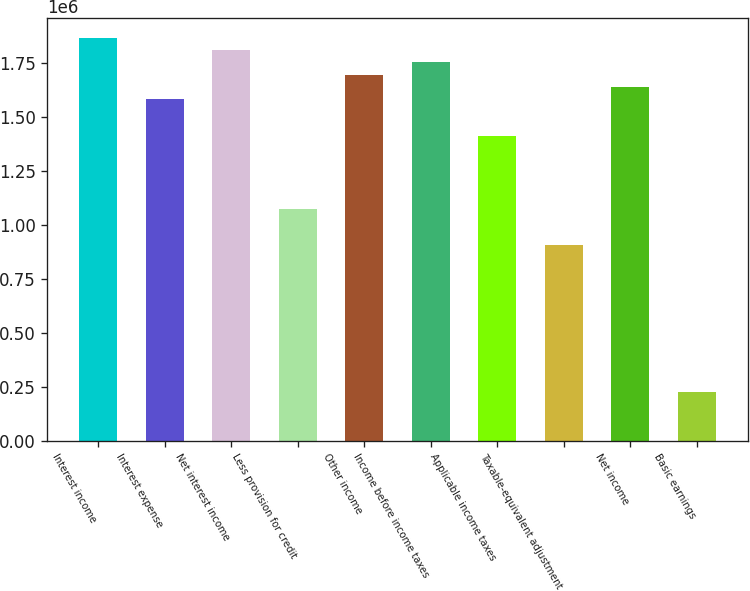Convert chart to OTSL. <chart><loc_0><loc_0><loc_500><loc_500><bar_chart><fcel>Interest income<fcel>Interest expense<fcel>Net interest income<fcel>Less provision for credit<fcel>Other income<fcel>Income before income taxes<fcel>Applicable income taxes<fcel>Taxable-equivalent adjustment<fcel>Net income<fcel>Basic earnings<nl><fcel>1.8648e+06<fcel>1.58225e+06<fcel>1.80829e+06<fcel>1.07367e+06<fcel>1.69527e+06<fcel>1.75178e+06<fcel>1.41272e+06<fcel>904144<fcel>1.63876e+06<fcel>226036<nl></chart> 